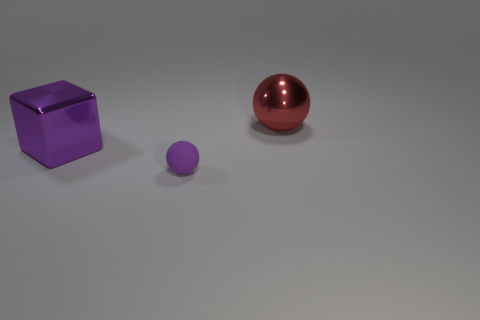Can you tell me the colors of the objects in the image? Certainly! In the image, there is a purple (or violet) cubic object, a smaller purple (or violet) spherical object, and a larger red spherical object. 